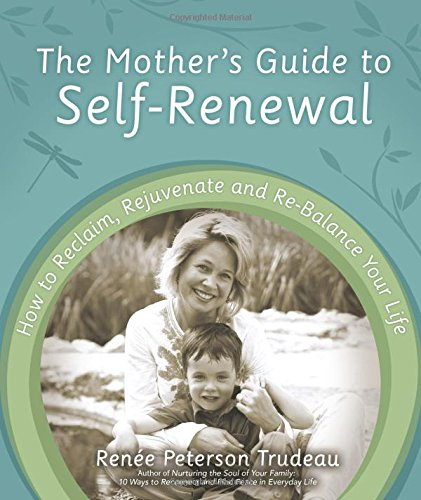Can you tell me more about the topics covered in this book? Certainly! The book covers a variety of topics crucial for mothers seeking personal growth. These include practical advice on creating personal time, managing stress, nurturing the soul, and enhancing relationships both within the family and externally. 